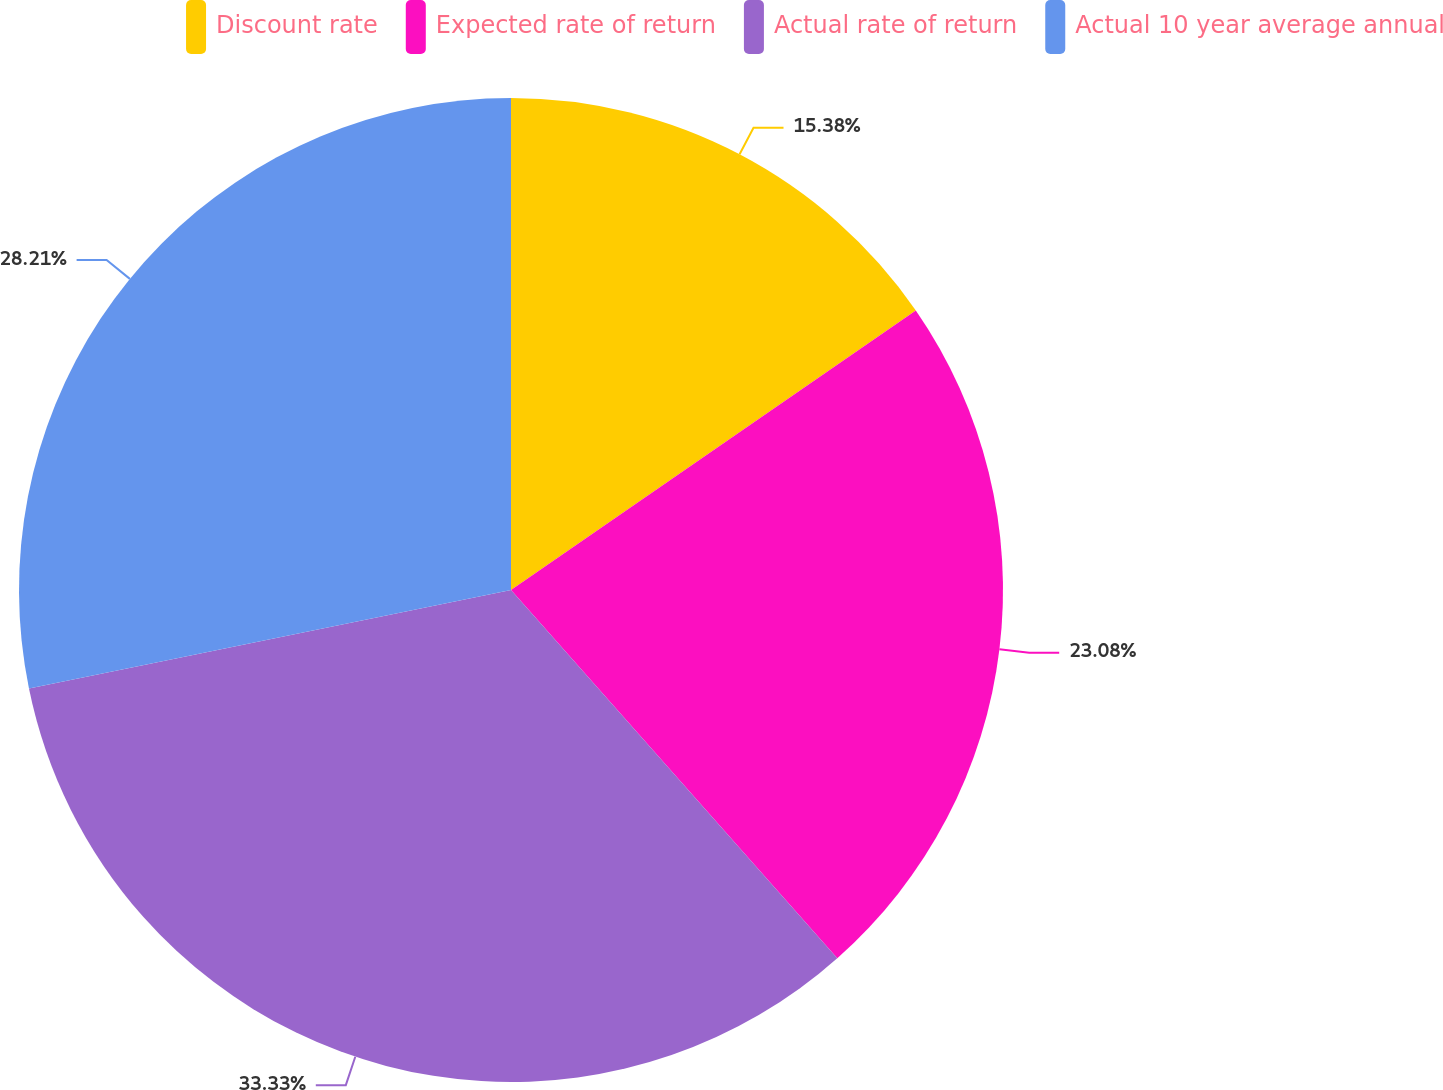<chart> <loc_0><loc_0><loc_500><loc_500><pie_chart><fcel>Discount rate<fcel>Expected rate of return<fcel>Actual rate of return<fcel>Actual 10 year average annual<nl><fcel>15.38%<fcel>23.08%<fcel>33.33%<fcel>28.21%<nl></chart> 